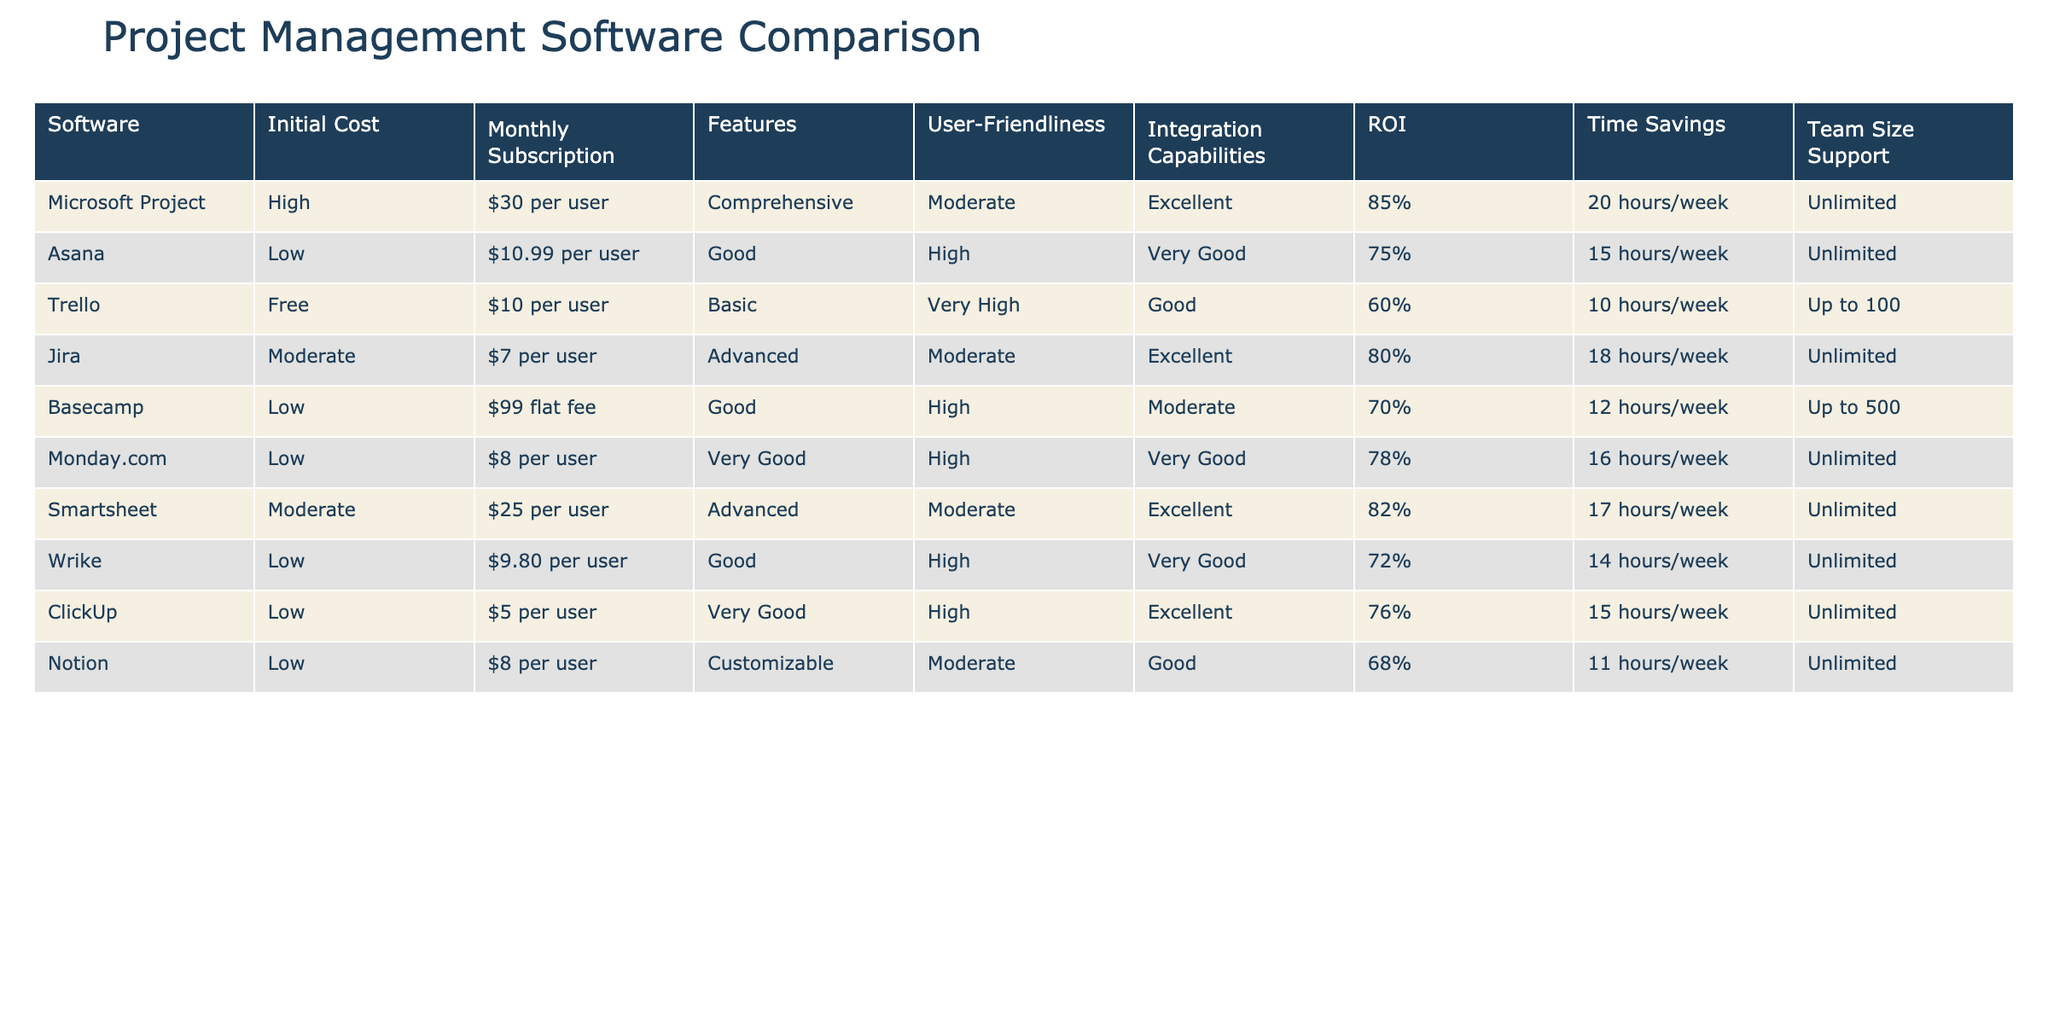What is the initial cost of Trello? The initial cost listed for Trello is "Free." This can be directly observed in the table under the "Initial Cost" column for Trello.
Answer: Free Which project management software has the highest ROI? According to the table, Microsoft Project has the highest ROI at 85%. This is evident when comparing the values under the ROI column for all software options.
Answer: 85% What is the average monthly subscription cost across all software? First, add the monthly subscription costs: 30 (Microsoft Project) + 10.99 (Asana) + 10 (Trello) + 7 (Jira) + 99 (Basecamp) + 8 (Monday.com) + 25 (Smartsheet) + 9.80 (Wrike) + 5 (ClickUp) + 8 (Notion) = 299.79. Then, divide by the number of software options, which is 10; therefore, the average is 299.79 / 10 = 29.979.
Answer: 29.98 Does any software support a team size of over 500 members? Yes, Basecamp has team size support for up to 500 members. This information can be confirmed by checking the "Team Size Support" column for Basecamp.
Answer: Yes Which software provides the most time savings per week? To find the software providing the most time savings, look at the "Time Savings" column and identify the highest value. Microsoft Project saves 20 hours per week, which is the most compared to other options in the table.
Answer: 20 hours/week Is there any software that offers a free initial cost with unlimited user support? Yes, Trello offers a free initial cost and supports an unlimited number of users. This can be validated by checking the "Initial Cost" and "Team Size Support" columns for Trello.
Answer: Yes What is the difference in ROI between Microsoft Project and ClickUp? The ROI for Microsoft Project is 85% and for ClickUp it is 76%. To find the difference, subtract ClickUp's ROI from Microsoft Project's: 85% - 76% = 9%.
Answer: 9% Which software has a monthly subscription cost of less than $10? The table shows that Jira ($7), ClickUp ($5), and Trello ($10) have monthly subscription costs below $10. By checking the "Monthly Subscription" column, we can identify these options.
Answer: Jira, ClickUp What is the user-friendliness level of the project management software with the lowest initial cost? The software with the lowest initial cost is ClickUp (with an initial cost of $5). According to the "User-Friendliness" column, ClickUp is rated as "High."
Answer: High 